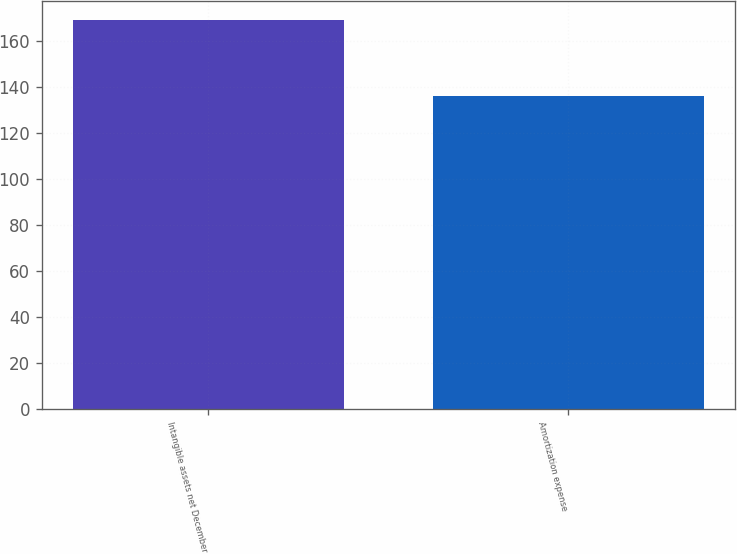Convert chart. <chart><loc_0><loc_0><loc_500><loc_500><bar_chart><fcel>Intangible assets net December<fcel>Amortization expense<nl><fcel>168.9<fcel>136<nl></chart> 